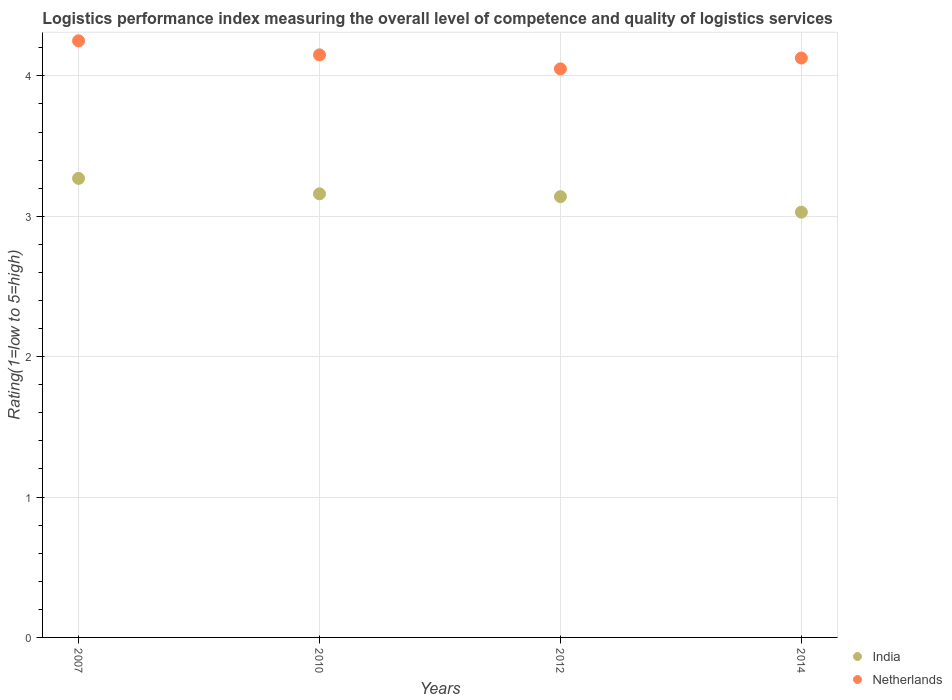What is the Logistic performance index in Netherlands in 2014?
Provide a succinct answer. 4.13. Across all years, what is the maximum Logistic performance index in Netherlands?
Offer a terse response. 4.25. Across all years, what is the minimum Logistic performance index in India?
Your answer should be compact. 3.03. In which year was the Logistic performance index in Netherlands maximum?
Offer a very short reply. 2007. In which year was the Logistic performance index in Netherlands minimum?
Your answer should be very brief. 2012. What is the total Logistic performance index in Netherlands in the graph?
Offer a terse response. 16.58. What is the difference between the Logistic performance index in Netherlands in 2012 and that in 2014?
Your answer should be very brief. -0.08. What is the difference between the Logistic performance index in Netherlands in 2007 and the Logistic performance index in India in 2010?
Your answer should be compact. 1.09. What is the average Logistic performance index in India per year?
Ensure brevity in your answer.  3.15. In the year 2010, what is the difference between the Logistic performance index in Netherlands and Logistic performance index in India?
Ensure brevity in your answer.  0.99. In how many years, is the Logistic performance index in Netherlands greater than 2.4?
Offer a very short reply. 4. What is the ratio of the Logistic performance index in Netherlands in 2007 to that in 2014?
Keep it short and to the point. 1.03. Is the difference between the Logistic performance index in Netherlands in 2007 and 2014 greater than the difference between the Logistic performance index in India in 2007 and 2014?
Make the answer very short. No. What is the difference between the highest and the second highest Logistic performance index in Netherlands?
Provide a short and direct response. 0.1. What is the difference between the highest and the lowest Logistic performance index in India?
Your answer should be compact. 0.24. In how many years, is the Logistic performance index in India greater than the average Logistic performance index in India taken over all years?
Your answer should be very brief. 2. Is the sum of the Logistic performance index in Netherlands in 2012 and 2014 greater than the maximum Logistic performance index in India across all years?
Keep it short and to the point. Yes. Is the Logistic performance index in Netherlands strictly greater than the Logistic performance index in India over the years?
Make the answer very short. Yes. What is the difference between two consecutive major ticks on the Y-axis?
Offer a very short reply. 1. Does the graph contain grids?
Your answer should be very brief. Yes. How many legend labels are there?
Make the answer very short. 2. How are the legend labels stacked?
Provide a short and direct response. Vertical. What is the title of the graph?
Offer a very short reply. Logistics performance index measuring the overall level of competence and quality of logistics services. What is the label or title of the Y-axis?
Offer a terse response. Rating(1=low to 5=high). What is the Rating(1=low to 5=high) in India in 2007?
Give a very brief answer. 3.27. What is the Rating(1=low to 5=high) in Netherlands in 2007?
Provide a short and direct response. 4.25. What is the Rating(1=low to 5=high) of India in 2010?
Your response must be concise. 3.16. What is the Rating(1=low to 5=high) of Netherlands in 2010?
Provide a succinct answer. 4.15. What is the Rating(1=low to 5=high) of India in 2012?
Make the answer very short. 3.14. What is the Rating(1=low to 5=high) of Netherlands in 2012?
Keep it short and to the point. 4.05. What is the Rating(1=low to 5=high) in India in 2014?
Provide a short and direct response. 3.03. What is the Rating(1=low to 5=high) in Netherlands in 2014?
Make the answer very short. 4.13. Across all years, what is the maximum Rating(1=low to 5=high) in India?
Provide a short and direct response. 3.27. Across all years, what is the maximum Rating(1=low to 5=high) of Netherlands?
Keep it short and to the point. 4.25. Across all years, what is the minimum Rating(1=low to 5=high) in India?
Provide a short and direct response. 3.03. Across all years, what is the minimum Rating(1=low to 5=high) of Netherlands?
Keep it short and to the point. 4.05. What is the total Rating(1=low to 5=high) of India in the graph?
Your answer should be compact. 12.6. What is the total Rating(1=low to 5=high) in Netherlands in the graph?
Ensure brevity in your answer.  16.58. What is the difference between the Rating(1=low to 5=high) of India in 2007 and that in 2010?
Give a very brief answer. 0.11. What is the difference between the Rating(1=low to 5=high) in India in 2007 and that in 2012?
Your answer should be compact. 0.13. What is the difference between the Rating(1=low to 5=high) of India in 2007 and that in 2014?
Provide a short and direct response. 0.24. What is the difference between the Rating(1=low to 5=high) in Netherlands in 2007 and that in 2014?
Make the answer very short. 0.12. What is the difference between the Rating(1=low to 5=high) of India in 2010 and that in 2012?
Provide a succinct answer. 0.02. What is the difference between the Rating(1=low to 5=high) in India in 2010 and that in 2014?
Provide a short and direct response. 0.13. What is the difference between the Rating(1=low to 5=high) of Netherlands in 2010 and that in 2014?
Give a very brief answer. 0.02. What is the difference between the Rating(1=low to 5=high) of India in 2012 and that in 2014?
Your response must be concise. 0.11. What is the difference between the Rating(1=low to 5=high) of Netherlands in 2012 and that in 2014?
Provide a succinct answer. -0.08. What is the difference between the Rating(1=low to 5=high) in India in 2007 and the Rating(1=low to 5=high) in Netherlands in 2010?
Your answer should be very brief. -0.88. What is the difference between the Rating(1=low to 5=high) of India in 2007 and the Rating(1=low to 5=high) of Netherlands in 2012?
Provide a succinct answer. -0.78. What is the difference between the Rating(1=low to 5=high) in India in 2007 and the Rating(1=low to 5=high) in Netherlands in 2014?
Your answer should be very brief. -0.86. What is the difference between the Rating(1=low to 5=high) in India in 2010 and the Rating(1=low to 5=high) in Netherlands in 2012?
Give a very brief answer. -0.89. What is the difference between the Rating(1=low to 5=high) in India in 2010 and the Rating(1=low to 5=high) in Netherlands in 2014?
Provide a short and direct response. -0.97. What is the difference between the Rating(1=low to 5=high) of India in 2012 and the Rating(1=low to 5=high) of Netherlands in 2014?
Keep it short and to the point. -0.99. What is the average Rating(1=low to 5=high) in India per year?
Make the answer very short. 3.15. What is the average Rating(1=low to 5=high) in Netherlands per year?
Your answer should be very brief. 4.14. In the year 2007, what is the difference between the Rating(1=low to 5=high) of India and Rating(1=low to 5=high) of Netherlands?
Ensure brevity in your answer.  -0.98. In the year 2010, what is the difference between the Rating(1=low to 5=high) in India and Rating(1=low to 5=high) in Netherlands?
Offer a very short reply. -0.99. In the year 2012, what is the difference between the Rating(1=low to 5=high) of India and Rating(1=low to 5=high) of Netherlands?
Your answer should be compact. -0.91. In the year 2014, what is the difference between the Rating(1=low to 5=high) of India and Rating(1=low to 5=high) of Netherlands?
Ensure brevity in your answer.  -1.1. What is the ratio of the Rating(1=low to 5=high) of India in 2007 to that in 2010?
Offer a terse response. 1.03. What is the ratio of the Rating(1=low to 5=high) in Netherlands in 2007 to that in 2010?
Provide a succinct answer. 1.02. What is the ratio of the Rating(1=low to 5=high) of India in 2007 to that in 2012?
Keep it short and to the point. 1.04. What is the ratio of the Rating(1=low to 5=high) in Netherlands in 2007 to that in 2012?
Ensure brevity in your answer.  1.05. What is the ratio of the Rating(1=low to 5=high) of India in 2007 to that in 2014?
Give a very brief answer. 1.08. What is the ratio of the Rating(1=low to 5=high) of Netherlands in 2007 to that in 2014?
Make the answer very short. 1.03. What is the ratio of the Rating(1=low to 5=high) in India in 2010 to that in 2012?
Give a very brief answer. 1.01. What is the ratio of the Rating(1=low to 5=high) of Netherlands in 2010 to that in 2012?
Offer a terse response. 1.02. What is the ratio of the Rating(1=low to 5=high) in India in 2010 to that in 2014?
Give a very brief answer. 1.04. What is the ratio of the Rating(1=low to 5=high) in Netherlands in 2010 to that in 2014?
Make the answer very short. 1.01. What is the ratio of the Rating(1=low to 5=high) of India in 2012 to that in 2014?
Your answer should be compact. 1.04. What is the ratio of the Rating(1=low to 5=high) in Netherlands in 2012 to that in 2014?
Your answer should be very brief. 0.98. What is the difference between the highest and the second highest Rating(1=low to 5=high) of India?
Your answer should be compact. 0.11. What is the difference between the highest and the second highest Rating(1=low to 5=high) of Netherlands?
Provide a succinct answer. 0.1. What is the difference between the highest and the lowest Rating(1=low to 5=high) of India?
Your response must be concise. 0.24. 